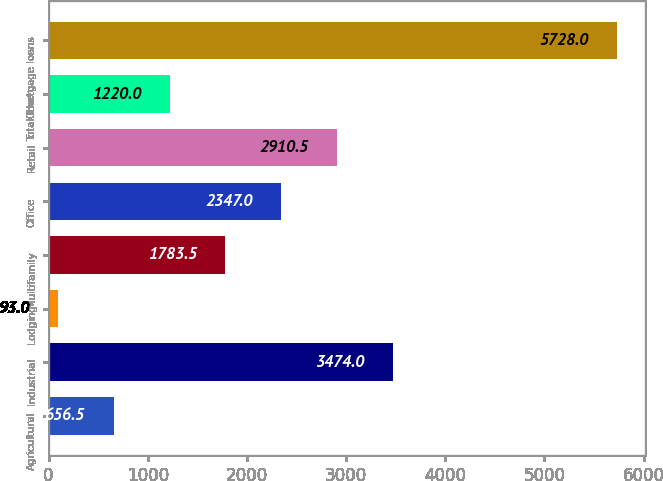<chart> <loc_0><loc_0><loc_500><loc_500><bar_chart><fcel>Agricultural<fcel>Industrial<fcel>Lodging<fcel>Multifamily<fcel>Office<fcel>Retail<fcel>Other<fcel>Total mortgage loans<nl><fcel>656.5<fcel>3474<fcel>93<fcel>1783.5<fcel>2347<fcel>2910.5<fcel>1220<fcel>5728<nl></chart> 